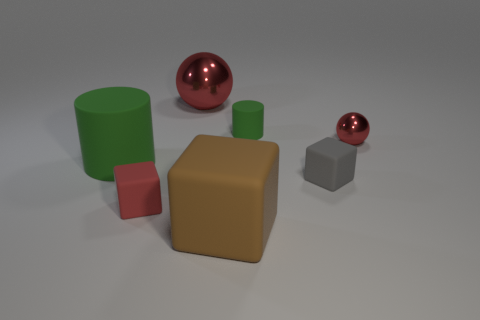Subtract all tiny matte cubes. How many cubes are left? 1 Add 1 brown things. How many objects exist? 8 Subtract all brown blocks. How many blocks are left? 2 Subtract 1 cylinders. How many cylinders are left? 1 Subtract all red cylinders. Subtract all cyan cubes. How many cylinders are left? 2 Subtract all gray metal objects. Subtract all red balls. How many objects are left? 5 Add 6 red rubber objects. How many red rubber objects are left? 7 Add 5 big brown cylinders. How many big brown cylinders exist? 5 Subtract 0 green balls. How many objects are left? 7 Subtract all spheres. How many objects are left? 5 